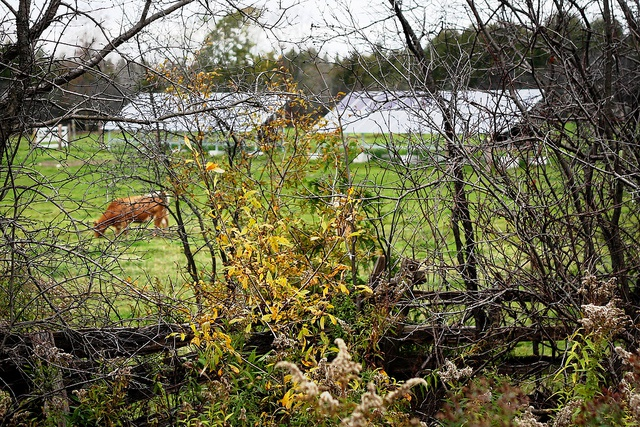Describe the objects in this image and their specific colors. I can see a cow in darkgray, brown, maroon, and gray tones in this image. 